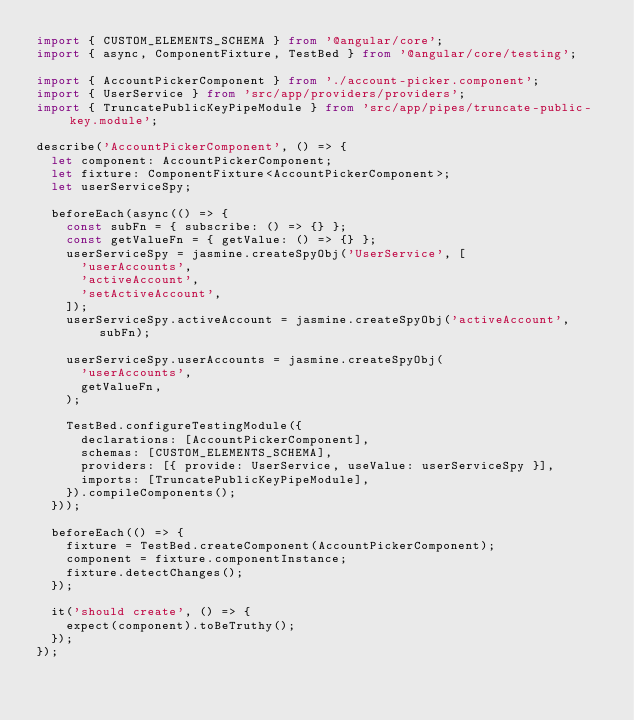<code> <loc_0><loc_0><loc_500><loc_500><_TypeScript_>import { CUSTOM_ELEMENTS_SCHEMA } from '@angular/core';
import { async, ComponentFixture, TestBed } from '@angular/core/testing';

import { AccountPickerComponent } from './account-picker.component';
import { UserService } from 'src/app/providers/providers';
import { TruncatePublicKeyPipeModule } from 'src/app/pipes/truncate-public-key.module';

describe('AccountPickerComponent', () => {
  let component: AccountPickerComponent;
  let fixture: ComponentFixture<AccountPickerComponent>;
  let userServiceSpy;

  beforeEach(async(() => {
    const subFn = { subscribe: () => {} };
    const getValueFn = { getValue: () => {} };
    userServiceSpy = jasmine.createSpyObj('UserService', [
      'userAccounts',
      'activeAccount',
      'setActiveAccount',
    ]);
    userServiceSpy.activeAccount = jasmine.createSpyObj('activeAccount', subFn);

    userServiceSpy.userAccounts = jasmine.createSpyObj(
      'userAccounts',
      getValueFn,
    );

    TestBed.configureTestingModule({
      declarations: [AccountPickerComponent],
      schemas: [CUSTOM_ELEMENTS_SCHEMA],
      providers: [{ provide: UserService, useValue: userServiceSpy }],
      imports: [TruncatePublicKeyPipeModule],
    }).compileComponents();
  }));

  beforeEach(() => {
    fixture = TestBed.createComponent(AccountPickerComponent);
    component = fixture.componentInstance;
    fixture.detectChanges();
  });

  it('should create', () => {
    expect(component).toBeTruthy();
  });
});
</code> 